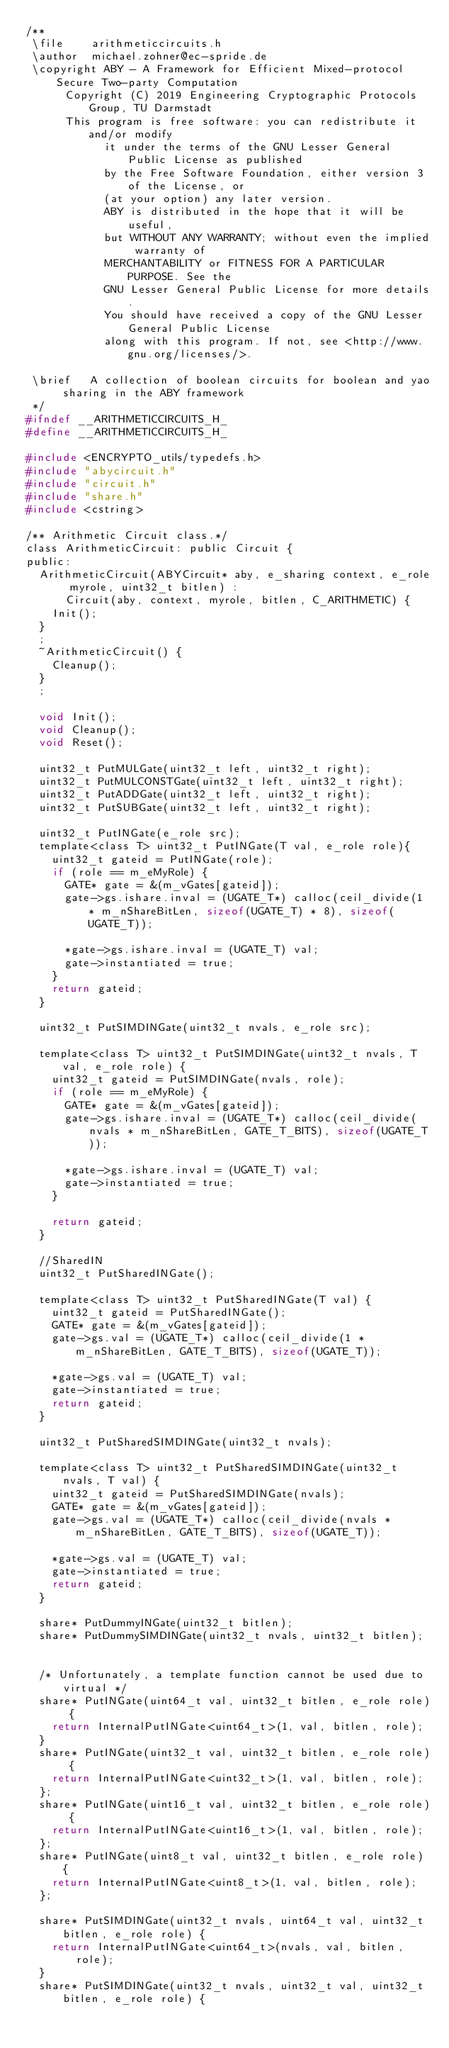<code> <loc_0><loc_0><loc_500><loc_500><_C_>/**
 \file		arithmeticcircuits.h
 \author	michael.zohner@ec-spride.de
 \copyright	ABY - A Framework for Efficient Mixed-protocol Secure Two-party Computation
			Copyright (C) 2019 Engineering Cryptographic Protocols Group, TU Darmstadt
			This program is free software: you can redistribute it and/or modify
            it under the terms of the GNU Lesser General Public License as published
            by the Free Software Foundation, either version 3 of the License, or
            (at your option) any later version.
            ABY is distributed in the hope that it will be useful,
            but WITHOUT ANY WARRANTY; without even the implied warranty of
            MERCHANTABILITY or FITNESS FOR A PARTICULAR PURPOSE. See the
            GNU Lesser General Public License for more details.
            You should have received a copy of the GNU Lesser General Public License
            along with this program. If not, see <http://www.gnu.org/licenses/>.

 \brief		A collection of boolean circuits for boolean and yao sharing in the ABY framework
 */
#ifndef __ARITHMETICCIRCUITS_H_
#define __ARITHMETICCIRCUITS_H_

#include <ENCRYPTO_utils/typedefs.h>
#include "abycircuit.h"
#include "circuit.h"
#include "share.h"
#include <cstring>

/** Arithmetic Circuit class.*/
class ArithmeticCircuit: public Circuit {
public:
	ArithmeticCircuit(ABYCircuit* aby, e_sharing context, e_role myrole, uint32_t bitlen) :
			Circuit(aby, context, myrole, bitlen, C_ARITHMETIC) {
		Init();
	}
	;
	~ArithmeticCircuit() {
		Cleanup();
	}
	;

	void Init();
	void Cleanup();
	void Reset();

	uint32_t PutMULGate(uint32_t left, uint32_t right);
	uint32_t PutMULCONSTGate(uint32_t left, uint32_t right);
	uint32_t PutADDGate(uint32_t left, uint32_t right);
	uint32_t PutSUBGate(uint32_t left, uint32_t right);

	uint32_t PutINGate(e_role src);
	template<class T> uint32_t PutINGate(T val, e_role role){
		uint32_t gateid = PutINGate(role);
		if (role == m_eMyRole) {
			GATE* gate = &(m_vGates[gateid]);
			gate->gs.ishare.inval = (UGATE_T*) calloc(ceil_divide(1 * m_nShareBitLen, sizeof(UGATE_T) * 8), sizeof(UGATE_T));

			*gate->gs.ishare.inval = (UGATE_T) val;
			gate->instantiated = true;
		}
		return gateid;
	}

	uint32_t PutSIMDINGate(uint32_t nvals, e_role src);

	template<class T> uint32_t PutSIMDINGate(uint32_t nvals, T val, e_role role) {
		uint32_t gateid = PutSIMDINGate(nvals, role);
		if (role == m_eMyRole) {
			GATE* gate = &(m_vGates[gateid]);
			gate->gs.ishare.inval = (UGATE_T*) calloc(ceil_divide(nvals * m_nShareBitLen, GATE_T_BITS), sizeof(UGATE_T));

			*gate->gs.ishare.inval = (UGATE_T) val;
			gate->instantiated = true;
		}

		return gateid;
	}

	//SharedIN
	uint32_t PutSharedINGate();

	template<class T> uint32_t PutSharedINGate(T val) {
		uint32_t gateid = PutSharedINGate();
		GATE* gate = &(m_vGates[gateid]);
		gate->gs.val = (UGATE_T*) calloc(ceil_divide(1 * m_nShareBitLen, GATE_T_BITS), sizeof(UGATE_T));

		*gate->gs.val = (UGATE_T) val;
		gate->instantiated = true;
		return gateid;
	}

	uint32_t PutSharedSIMDINGate(uint32_t nvals);

	template<class T> uint32_t PutSharedSIMDINGate(uint32_t nvals, T val) {
		uint32_t gateid = PutSharedSIMDINGate(nvals);
		GATE* gate = &(m_vGates[gateid]);
		gate->gs.val = (UGATE_T*) calloc(ceil_divide(nvals * m_nShareBitLen, GATE_T_BITS), sizeof(UGATE_T));

		*gate->gs.val = (UGATE_T) val;
		gate->instantiated = true;
		return gateid;
	}

	share* PutDummyINGate(uint32_t bitlen);
	share* PutDummySIMDINGate(uint32_t nvals, uint32_t bitlen);


	/* Unfortunately, a template function cannot be used due to virtual */
	share* PutINGate(uint64_t val, uint32_t bitlen, e_role role) {
		return InternalPutINGate<uint64_t>(1, val, bitlen, role);
	}
	share* PutINGate(uint32_t val, uint32_t bitlen, e_role role) {
		return InternalPutINGate<uint32_t>(1, val, bitlen, role);
	};
	share* PutINGate(uint16_t val, uint32_t bitlen, e_role role) {
		return InternalPutINGate<uint16_t>(1, val, bitlen, role);
	};
	share* PutINGate(uint8_t val, uint32_t bitlen, e_role role) {
		return InternalPutINGate<uint8_t>(1, val, bitlen, role);
	};

	share* PutSIMDINGate(uint32_t nvals, uint64_t val, uint32_t bitlen, e_role role) {
		return InternalPutINGate<uint64_t>(nvals, val, bitlen, role);
	}
	share* PutSIMDINGate(uint32_t nvals, uint32_t val, uint32_t bitlen, e_role role) {</code> 